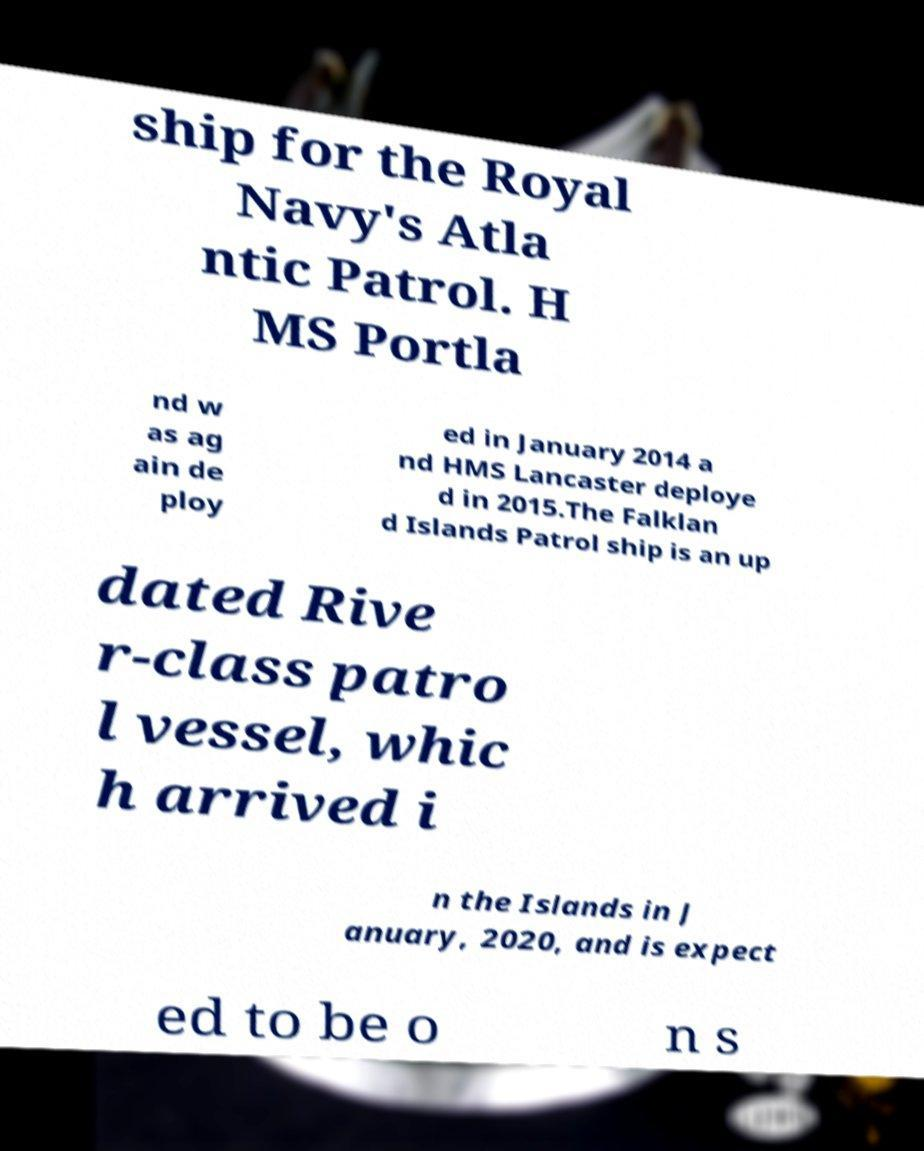What messages or text are displayed in this image? I need them in a readable, typed format. ship for the Royal Navy's Atla ntic Patrol. H MS Portla nd w as ag ain de ploy ed in January 2014 a nd HMS Lancaster deploye d in 2015.The Falklan d Islands Patrol ship is an up dated Rive r-class patro l vessel, whic h arrived i n the Islands in J anuary, 2020, and is expect ed to be o n s 